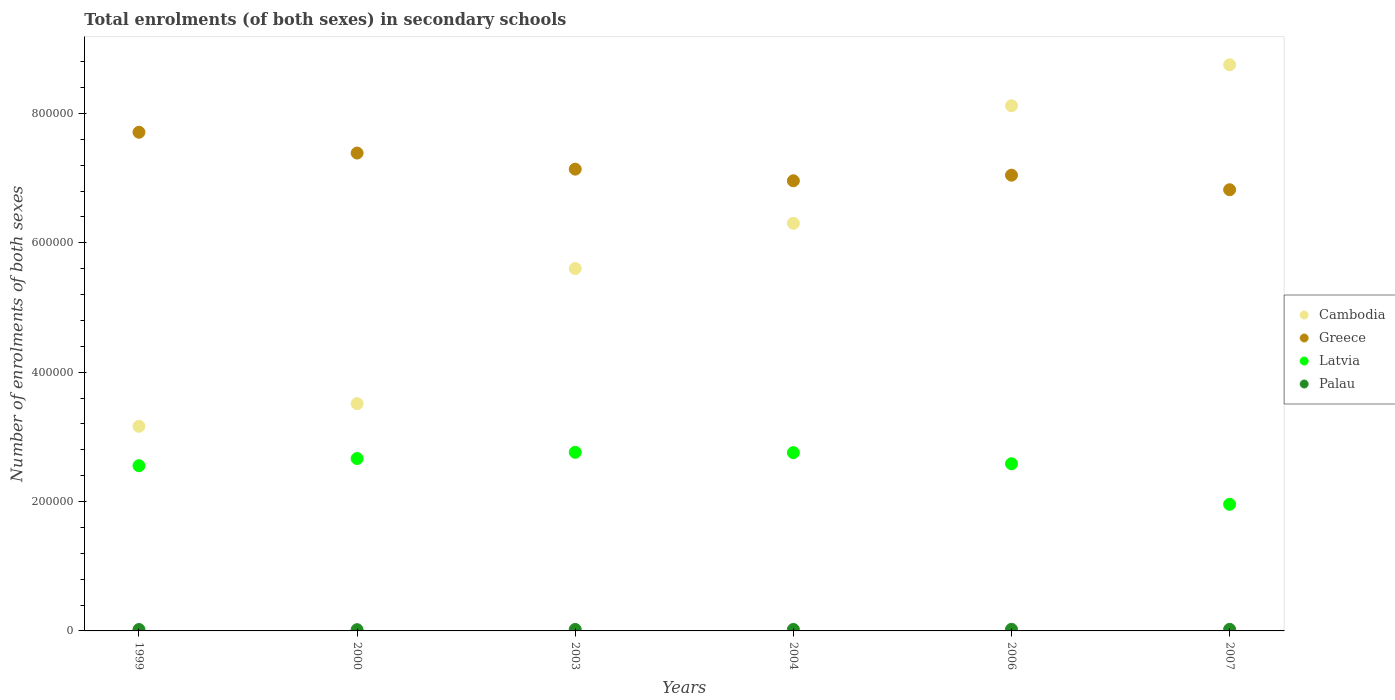How many different coloured dotlines are there?
Give a very brief answer. 4. Is the number of dotlines equal to the number of legend labels?
Ensure brevity in your answer.  Yes. What is the number of enrolments in secondary schools in Cambodia in 2006?
Your response must be concise. 8.12e+05. Across all years, what is the maximum number of enrolments in secondary schools in Latvia?
Your answer should be compact. 2.76e+05. Across all years, what is the minimum number of enrolments in secondary schools in Latvia?
Keep it short and to the point. 1.96e+05. In which year was the number of enrolments in secondary schools in Palau minimum?
Provide a short and direct response. 2000. What is the total number of enrolments in secondary schools in Greece in the graph?
Offer a very short reply. 4.31e+06. What is the difference between the number of enrolments in secondary schools in Greece in 2003 and that in 2004?
Your answer should be compact. 1.80e+04. What is the difference between the number of enrolments in secondary schools in Palau in 1999 and the number of enrolments in secondary schools in Greece in 2000?
Your answer should be compact. -7.37e+05. What is the average number of enrolments in secondary schools in Palau per year?
Provide a short and direct response. 2260.67. In the year 2003, what is the difference between the number of enrolments in secondary schools in Palau and number of enrolments in secondary schools in Latvia?
Ensure brevity in your answer.  -2.74e+05. What is the ratio of the number of enrolments in secondary schools in Cambodia in 2006 to that in 2007?
Offer a terse response. 0.93. Is the difference between the number of enrolments in secondary schools in Palau in 2000 and 2003 greater than the difference between the number of enrolments in secondary schools in Latvia in 2000 and 2003?
Your answer should be very brief. Yes. What is the difference between the highest and the second highest number of enrolments in secondary schools in Cambodia?
Offer a terse response. 6.33e+04. What is the difference between the highest and the lowest number of enrolments in secondary schools in Greece?
Ensure brevity in your answer.  8.89e+04. In how many years, is the number of enrolments in secondary schools in Cambodia greater than the average number of enrolments in secondary schools in Cambodia taken over all years?
Offer a very short reply. 3. Is the sum of the number of enrolments in secondary schools in Cambodia in 2000 and 2006 greater than the maximum number of enrolments in secondary schools in Greece across all years?
Your answer should be very brief. Yes. Is it the case that in every year, the sum of the number of enrolments in secondary schools in Palau and number of enrolments in secondary schools in Greece  is greater than the number of enrolments in secondary schools in Cambodia?
Provide a short and direct response. No. Does the number of enrolments in secondary schools in Palau monotonically increase over the years?
Provide a short and direct response. No. Is the number of enrolments in secondary schools in Cambodia strictly greater than the number of enrolments in secondary schools in Latvia over the years?
Your answer should be very brief. Yes. How many dotlines are there?
Your answer should be very brief. 4. How many years are there in the graph?
Your answer should be compact. 6. What is the difference between two consecutive major ticks on the Y-axis?
Keep it short and to the point. 2.00e+05. Does the graph contain any zero values?
Your response must be concise. No. What is the title of the graph?
Provide a short and direct response. Total enrolments (of both sexes) in secondary schools. Does "North America" appear as one of the legend labels in the graph?
Your response must be concise. No. What is the label or title of the X-axis?
Ensure brevity in your answer.  Years. What is the label or title of the Y-axis?
Offer a very short reply. Number of enrolments of both sexes. What is the Number of enrolments of both sexes in Cambodia in 1999?
Your response must be concise. 3.16e+05. What is the Number of enrolments of both sexes in Greece in 1999?
Your answer should be compact. 7.71e+05. What is the Number of enrolments of both sexes of Latvia in 1999?
Provide a succinct answer. 2.55e+05. What is the Number of enrolments of both sexes of Palau in 1999?
Offer a very short reply. 2177. What is the Number of enrolments of both sexes of Cambodia in 2000?
Your response must be concise. 3.51e+05. What is the Number of enrolments of both sexes of Greece in 2000?
Provide a short and direct response. 7.39e+05. What is the Number of enrolments of both sexes in Latvia in 2000?
Give a very brief answer. 2.66e+05. What is the Number of enrolments of both sexes in Palau in 2000?
Offer a terse response. 1901. What is the Number of enrolments of both sexes of Cambodia in 2003?
Your response must be concise. 5.60e+05. What is the Number of enrolments of both sexes in Greece in 2003?
Offer a very short reply. 7.14e+05. What is the Number of enrolments of both sexes in Latvia in 2003?
Your answer should be compact. 2.76e+05. What is the Number of enrolments of both sexes of Palau in 2003?
Your answer should be very brief. 2271. What is the Number of enrolments of both sexes in Cambodia in 2004?
Provide a short and direct response. 6.30e+05. What is the Number of enrolments of both sexes in Greece in 2004?
Make the answer very short. 6.96e+05. What is the Number of enrolments of both sexes in Latvia in 2004?
Provide a succinct answer. 2.76e+05. What is the Number of enrolments of both sexes in Palau in 2004?
Your answer should be compact. 2273. What is the Number of enrolments of both sexes in Cambodia in 2006?
Give a very brief answer. 8.12e+05. What is the Number of enrolments of both sexes of Greece in 2006?
Your response must be concise. 7.05e+05. What is the Number of enrolments of both sexes in Latvia in 2006?
Make the answer very short. 2.58e+05. What is the Number of enrolments of both sexes in Palau in 2006?
Your response must be concise. 2494. What is the Number of enrolments of both sexes of Cambodia in 2007?
Offer a terse response. 8.75e+05. What is the Number of enrolments of both sexes of Greece in 2007?
Offer a terse response. 6.82e+05. What is the Number of enrolments of both sexes of Latvia in 2007?
Provide a short and direct response. 1.96e+05. What is the Number of enrolments of both sexes of Palau in 2007?
Your answer should be very brief. 2448. Across all years, what is the maximum Number of enrolments of both sexes in Cambodia?
Provide a short and direct response. 8.75e+05. Across all years, what is the maximum Number of enrolments of both sexes in Greece?
Provide a short and direct response. 7.71e+05. Across all years, what is the maximum Number of enrolments of both sexes of Latvia?
Provide a short and direct response. 2.76e+05. Across all years, what is the maximum Number of enrolments of both sexes in Palau?
Ensure brevity in your answer.  2494. Across all years, what is the minimum Number of enrolments of both sexes in Cambodia?
Make the answer very short. 3.16e+05. Across all years, what is the minimum Number of enrolments of both sexes in Greece?
Keep it short and to the point. 6.82e+05. Across all years, what is the minimum Number of enrolments of both sexes of Latvia?
Provide a short and direct response. 1.96e+05. Across all years, what is the minimum Number of enrolments of both sexes in Palau?
Your answer should be compact. 1901. What is the total Number of enrolments of both sexes in Cambodia in the graph?
Keep it short and to the point. 3.54e+06. What is the total Number of enrolments of both sexes of Greece in the graph?
Offer a very short reply. 4.31e+06. What is the total Number of enrolments of both sexes of Latvia in the graph?
Ensure brevity in your answer.  1.53e+06. What is the total Number of enrolments of both sexes in Palau in the graph?
Provide a short and direct response. 1.36e+04. What is the difference between the Number of enrolments of both sexes of Cambodia in 1999 and that in 2000?
Offer a terse response. -3.50e+04. What is the difference between the Number of enrolments of both sexes of Greece in 1999 and that in 2000?
Give a very brief answer. 3.21e+04. What is the difference between the Number of enrolments of both sexes in Latvia in 1999 and that in 2000?
Make the answer very short. -1.11e+04. What is the difference between the Number of enrolments of both sexes of Palau in 1999 and that in 2000?
Your answer should be compact. 276. What is the difference between the Number of enrolments of both sexes of Cambodia in 1999 and that in 2003?
Give a very brief answer. -2.44e+05. What is the difference between the Number of enrolments of both sexes of Greece in 1999 and that in 2003?
Give a very brief answer. 5.70e+04. What is the difference between the Number of enrolments of both sexes in Latvia in 1999 and that in 2003?
Your answer should be very brief. -2.07e+04. What is the difference between the Number of enrolments of both sexes of Palau in 1999 and that in 2003?
Keep it short and to the point. -94. What is the difference between the Number of enrolments of both sexes in Cambodia in 1999 and that in 2004?
Your response must be concise. -3.14e+05. What is the difference between the Number of enrolments of both sexes of Greece in 1999 and that in 2004?
Provide a short and direct response. 7.50e+04. What is the difference between the Number of enrolments of both sexes in Latvia in 1999 and that in 2004?
Give a very brief answer. -2.02e+04. What is the difference between the Number of enrolments of both sexes of Palau in 1999 and that in 2004?
Provide a succinct answer. -96. What is the difference between the Number of enrolments of both sexes in Cambodia in 1999 and that in 2006?
Your answer should be very brief. -4.95e+05. What is the difference between the Number of enrolments of both sexes of Greece in 1999 and that in 2006?
Give a very brief answer. 6.64e+04. What is the difference between the Number of enrolments of both sexes of Latvia in 1999 and that in 2006?
Provide a succinct answer. -3051. What is the difference between the Number of enrolments of both sexes of Palau in 1999 and that in 2006?
Make the answer very short. -317. What is the difference between the Number of enrolments of both sexes of Cambodia in 1999 and that in 2007?
Provide a short and direct response. -5.59e+05. What is the difference between the Number of enrolments of both sexes in Greece in 1999 and that in 2007?
Provide a short and direct response. 8.89e+04. What is the difference between the Number of enrolments of both sexes in Latvia in 1999 and that in 2007?
Your response must be concise. 5.96e+04. What is the difference between the Number of enrolments of both sexes of Palau in 1999 and that in 2007?
Provide a short and direct response. -271. What is the difference between the Number of enrolments of both sexes in Cambodia in 2000 and that in 2003?
Your response must be concise. -2.09e+05. What is the difference between the Number of enrolments of both sexes in Greece in 2000 and that in 2003?
Give a very brief answer. 2.49e+04. What is the difference between the Number of enrolments of both sexes of Latvia in 2000 and that in 2003?
Make the answer very short. -9574. What is the difference between the Number of enrolments of both sexes in Palau in 2000 and that in 2003?
Make the answer very short. -370. What is the difference between the Number of enrolments of both sexes of Cambodia in 2000 and that in 2004?
Keep it short and to the point. -2.79e+05. What is the difference between the Number of enrolments of both sexes in Greece in 2000 and that in 2004?
Your response must be concise. 4.29e+04. What is the difference between the Number of enrolments of both sexes in Latvia in 2000 and that in 2004?
Provide a succinct answer. -9088. What is the difference between the Number of enrolments of both sexes in Palau in 2000 and that in 2004?
Give a very brief answer. -372. What is the difference between the Number of enrolments of both sexes in Cambodia in 2000 and that in 2006?
Your answer should be very brief. -4.60e+05. What is the difference between the Number of enrolments of both sexes in Greece in 2000 and that in 2006?
Give a very brief answer. 3.42e+04. What is the difference between the Number of enrolments of both sexes of Latvia in 2000 and that in 2006?
Your answer should be compact. 8066. What is the difference between the Number of enrolments of both sexes in Palau in 2000 and that in 2006?
Offer a very short reply. -593. What is the difference between the Number of enrolments of both sexes of Cambodia in 2000 and that in 2007?
Offer a very short reply. -5.24e+05. What is the difference between the Number of enrolments of both sexes in Greece in 2000 and that in 2007?
Ensure brevity in your answer.  5.67e+04. What is the difference between the Number of enrolments of both sexes of Latvia in 2000 and that in 2007?
Your answer should be very brief. 7.08e+04. What is the difference between the Number of enrolments of both sexes of Palau in 2000 and that in 2007?
Your answer should be compact. -547. What is the difference between the Number of enrolments of both sexes of Cambodia in 2003 and that in 2004?
Offer a terse response. -6.99e+04. What is the difference between the Number of enrolments of both sexes in Greece in 2003 and that in 2004?
Your answer should be very brief. 1.80e+04. What is the difference between the Number of enrolments of both sexes in Latvia in 2003 and that in 2004?
Keep it short and to the point. 486. What is the difference between the Number of enrolments of both sexes of Cambodia in 2003 and that in 2006?
Keep it short and to the point. -2.52e+05. What is the difference between the Number of enrolments of both sexes of Greece in 2003 and that in 2006?
Make the answer very short. 9335. What is the difference between the Number of enrolments of both sexes in Latvia in 2003 and that in 2006?
Provide a short and direct response. 1.76e+04. What is the difference between the Number of enrolments of both sexes in Palau in 2003 and that in 2006?
Offer a terse response. -223. What is the difference between the Number of enrolments of both sexes of Cambodia in 2003 and that in 2007?
Make the answer very short. -3.15e+05. What is the difference between the Number of enrolments of both sexes of Greece in 2003 and that in 2007?
Make the answer very short. 3.18e+04. What is the difference between the Number of enrolments of both sexes of Latvia in 2003 and that in 2007?
Give a very brief answer. 8.03e+04. What is the difference between the Number of enrolments of both sexes of Palau in 2003 and that in 2007?
Give a very brief answer. -177. What is the difference between the Number of enrolments of both sexes in Cambodia in 2004 and that in 2006?
Provide a short and direct response. -1.82e+05. What is the difference between the Number of enrolments of both sexes of Greece in 2004 and that in 2006?
Provide a short and direct response. -8677. What is the difference between the Number of enrolments of both sexes in Latvia in 2004 and that in 2006?
Your answer should be compact. 1.72e+04. What is the difference between the Number of enrolments of both sexes of Palau in 2004 and that in 2006?
Give a very brief answer. -221. What is the difference between the Number of enrolments of both sexes in Cambodia in 2004 and that in 2007?
Provide a succinct answer. -2.45e+05. What is the difference between the Number of enrolments of both sexes of Greece in 2004 and that in 2007?
Offer a very short reply. 1.38e+04. What is the difference between the Number of enrolments of both sexes of Latvia in 2004 and that in 2007?
Provide a short and direct response. 7.98e+04. What is the difference between the Number of enrolments of both sexes of Palau in 2004 and that in 2007?
Offer a very short reply. -175. What is the difference between the Number of enrolments of both sexes of Cambodia in 2006 and that in 2007?
Provide a short and direct response. -6.33e+04. What is the difference between the Number of enrolments of both sexes of Greece in 2006 and that in 2007?
Give a very brief answer. 2.25e+04. What is the difference between the Number of enrolments of both sexes in Latvia in 2006 and that in 2007?
Offer a terse response. 6.27e+04. What is the difference between the Number of enrolments of both sexes in Cambodia in 1999 and the Number of enrolments of both sexes in Greece in 2000?
Keep it short and to the point. -4.22e+05. What is the difference between the Number of enrolments of both sexes in Cambodia in 1999 and the Number of enrolments of both sexes in Latvia in 2000?
Make the answer very short. 4.98e+04. What is the difference between the Number of enrolments of both sexes of Cambodia in 1999 and the Number of enrolments of both sexes of Palau in 2000?
Offer a terse response. 3.14e+05. What is the difference between the Number of enrolments of both sexes of Greece in 1999 and the Number of enrolments of both sexes of Latvia in 2000?
Offer a very short reply. 5.04e+05. What is the difference between the Number of enrolments of both sexes in Greece in 1999 and the Number of enrolments of both sexes in Palau in 2000?
Offer a terse response. 7.69e+05. What is the difference between the Number of enrolments of both sexes in Latvia in 1999 and the Number of enrolments of both sexes in Palau in 2000?
Make the answer very short. 2.53e+05. What is the difference between the Number of enrolments of both sexes of Cambodia in 1999 and the Number of enrolments of both sexes of Greece in 2003?
Offer a very short reply. -3.98e+05. What is the difference between the Number of enrolments of both sexes of Cambodia in 1999 and the Number of enrolments of both sexes of Latvia in 2003?
Make the answer very short. 4.03e+04. What is the difference between the Number of enrolments of both sexes of Cambodia in 1999 and the Number of enrolments of both sexes of Palau in 2003?
Your response must be concise. 3.14e+05. What is the difference between the Number of enrolments of both sexes of Greece in 1999 and the Number of enrolments of both sexes of Latvia in 2003?
Your answer should be very brief. 4.95e+05. What is the difference between the Number of enrolments of both sexes of Greece in 1999 and the Number of enrolments of both sexes of Palau in 2003?
Offer a terse response. 7.69e+05. What is the difference between the Number of enrolments of both sexes in Latvia in 1999 and the Number of enrolments of both sexes in Palau in 2003?
Your response must be concise. 2.53e+05. What is the difference between the Number of enrolments of both sexes in Cambodia in 1999 and the Number of enrolments of both sexes in Greece in 2004?
Keep it short and to the point. -3.79e+05. What is the difference between the Number of enrolments of both sexes of Cambodia in 1999 and the Number of enrolments of both sexes of Latvia in 2004?
Ensure brevity in your answer.  4.08e+04. What is the difference between the Number of enrolments of both sexes in Cambodia in 1999 and the Number of enrolments of both sexes in Palau in 2004?
Give a very brief answer. 3.14e+05. What is the difference between the Number of enrolments of both sexes in Greece in 1999 and the Number of enrolments of both sexes in Latvia in 2004?
Your answer should be compact. 4.95e+05. What is the difference between the Number of enrolments of both sexes in Greece in 1999 and the Number of enrolments of both sexes in Palau in 2004?
Make the answer very short. 7.69e+05. What is the difference between the Number of enrolments of both sexes of Latvia in 1999 and the Number of enrolments of both sexes of Palau in 2004?
Provide a short and direct response. 2.53e+05. What is the difference between the Number of enrolments of both sexes of Cambodia in 1999 and the Number of enrolments of both sexes of Greece in 2006?
Your answer should be compact. -3.88e+05. What is the difference between the Number of enrolments of both sexes of Cambodia in 1999 and the Number of enrolments of both sexes of Latvia in 2006?
Provide a short and direct response. 5.79e+04. What is the difference between the Number of enrolments of both sexes of Cambodia in 1999 and the Number of enrolments of both sexes of Palau in 2006?
Ensure brevity in your answer.  3.14e+05. What is the difference between the Number of enrolments of both sexes of Greece in 1999 and the Number of enrolments of both sexes of Latvia in 2006?
Your answer should be compact. 5.12e+05. What is the difference between the Number of enrolments of both sexes in Greece in 1999 and the Number of enrolments of both sexes in Palau in 2006?
Ensure brevity in your answer.  7.68e+05. What is the difference between the Number of enrolments of both sexes in Latvia in 1999 and the Number of enrolments of both sexes in Palau in 2006?
Your response must be concise. 2.53e+05. What is the difference between the Number of enrolments of both sexes of Cambodia in 1999 and the Number of enrolments of both sexes of Greece in 2007?
Offer a very short reply. -3.66e+05. What is the difference between the Number of enrolments of both sexes in Cambodia in 1999 and the Number of enrolments of both sexes in Latvia in 2007?
Offer a very short reply. 1.21e+05. What is the difference between the Number of enrolments of both sexes of Cambodia in 1999 and the Number of enrolments of both sexes of Palau in 2007?
Keep it short and to the point. 3.14e+05. What is the difference between the Number of enrolments of both sexes in Greece in 1999 and the Number of enrolments of both sexes in Latvia in 2007?
Your response must be concise. 5.75e+05. What is the difference between the Number of enrolments of both sexes of Greece in 1999 and the Number of enrolments of both sexes of Palau in 2007?
Offer a terse response. 7.68e+05. What is the difference between the Number of enrolments of both sexes of Latvia in 1999 and the Number of enrolments of both sexes of Palau in 2007?
Provide a succinct answer. 2.53e+05. What is the difference between the Number of enrolments of both sexes in Cambodia in 2000 and the Number of enrolments of both sexes in Greece in 2003?
Your answer should be compact. -3.62e+05. What is the difference between the Number of enrolments of both sexes in Cambodia in 2000 and the Number of enrolments of both sexes in Latvia in 2003?
Keep it short and to the point. 7.53e+04. What is the difference between the Number of enrolments of both sexes of Cambodia in 2000 and the Number of enrolments of both sexes of Palau in 2003?
Your answer should be compact. 3.49e+05. What is the difference between the Number of enrolments of both sexes of Greece in 2000 and the Number of enrolments of both sexes of Latvia in 2003?
Offer a very short reply. 4.63e+05. What is the difference between the Number of enrolments of both sexes of Greece in 2000 and the Number of enrolments of both sexes of Palau in 2003?
Give a very brief answer. 7.36e+05. What is the difference between the Number of enrolments of both sexes in Latvia in 2000 and the Number of enrolments of both sexes in Palau in 2003?
Your response must be concise. 2.64e+05. What is the difference between the Number of enrolments of both sexes of Cambodia in 2000 and the Number of enrolments of both sexes of Greece in 2004?
Give a very brief answer. -3.44e+05. What is the difference between the Number of enrolments of both sexes in Cambodia in 2000 and the Number of enrolments of both sexes in Latvia in 2004?
Ensure brevity in your answer.  7.58e+04. What is the difference between the Number of enrolments of both sexes in Cambodia in 2000 and the Number of enrolments of both sexes in Palau in 2004?
Your answer should be very brief. 3.49e+05. What is the difference between the Number of enrolments of both sexes of Greece in 2000 and the Number of enrolments of both sexes of Latvia in 2004?
Your answer should be very brief. 4.63e+05. What is the difference between the Number of enrolments of both sexes of Greece in 2000 and the Number of enrolments of both sexes of Palau in 2004?
Your answer should be very brief. 7.36e+05. What is the difference between the Number of enrolments of both sexes of Latvia in 2000 and the Number of enrolments of both sexes of Palau in 2004?
Your response must be concise. 2.64e+05. What is the difference between the Number of enrolments of both sexes in Cambodia in 2000 and the Number of enrolments of both sexes in Greece in 2006?
Your answer should be compact. -3.53e+05. What is the difference between the Number of enrolments of both sexes in Cambodia in 2000 and the Number of enrolments of both sexes in Latvia in 2006?
Provide a short and direct response. 9.29e+04. What is the difference between the Number of enrolments of both sexes of Cambodia in 2000 and the Number of enrolments of both sexes of Palau in 2006?
Offer a terse response. 3.49e+05. What is the difference between the Number of enrolments of both sexes in Greece in 2000 and the Number of enrolments of both sexes in Latvia in 2006?
Offer a very short reply. 4.80e+05. What is the difference between the Number of enrolments of both sexes of Greece in 2000 and the Number of enrolments of both sexes of Palau in 2006?
Your answer should be very brief. 7.36e+05. What is the difference between the Number of enrolments of both sexes in Latvia in 2000 and the Number of enrolments of both sexes in Palau in 2006?
Offer a terse response. 2.64e+05. What is the difference between the Number of enrolments of both sexes in Cambodia in 2000 and the Number of enrolments of both sexes in Greece in 2007?
Your response must be concise. -3.31e+05. What is the difference between the Number of enrolments of both sexes of Cambodia in 2000 and the Number of enrolments of both sexes of Latvia in 2007?
Keep it short and to the point. 1.56e+05. What is the difference between the Number of enrolments of both sexes of Cambodia in 2000 and the Number of enrolments of both sexes of Palau in 2007?
Offer a very short reply. 3.49e+05. What is the difference between the Number of enrolments of both sexes of Greece in 2000 and the Number of enrolments of both sexes of Latvia in 2007?
Make the answer very short. 5.43e+05. What is the difference between the Number of enrolments of both sexes in Greece in 2000 and the Number of enrolments of both sexes in Palau in 2007?
Ensure brevity in your answer.  7.36e+05. What is the difference between the Number of enrolments of both sexes in Latvia in 2000 and the Number of enrolments of both sexes in Palau in 2007?
Ensure brevity in your answer.  2.64e+05. What is the difference between the Number of enrolments of both sexes in Cambodia in 2003 and the Number of enrolments of both sexes in Greece in 2004?
Provide a succinct answer. -1.36e+05. What is the difference between the Number of enrolments of both sexes of Cambodia in 2003 and the Number of enrolments of both sexes of Latvia in 2004?
Keep it short and to the point. 2.85e+05. What is the difference between the Number of enrolments of both sexes of Cambodia in 2003 and the Number of enrolments of both sexes of Palau in 2004?
Ensure brevity in your answer.  5.58e+05. What is the difference between the Number of enrolments of both sexes of Greece in 2003 and the Number of enrolments of both sexes of Latvia in 2004?
Give a very brief answer. 4.38e+05. What is the difference between the Number of enrolments of both sexes of Greece in 2003 and the Number of enrolments of both sexes of Palau in 2004?
Give a very brief answer. 7.12e+05. What is the difference between the Number of enrolments of both sexes in Latvia in 2003 and the Number of enrolments of both sexes in Palau in 2004?
Keep it short and to the point. 2.74e+05. What is the difference between the Number of enrolments of both sexes in Cambodia in 2003 and the Number of enrolments of both sexes in Greece in 2006?
Offer a very short reply. -1.44e+05. What is the difference between the Number of enrolments of both sexes in Cambodia in 2003 and the Number of enrolments of both sexes in Latvia in 2006?
Give a very brief answer. 3.02e+05. What is the difference between the Number of enrolments of both sexes in Cambodia in 2003 and the Number of enrolments of both sexes in Palau in 2006?
Your response must be concise. 5.58e+05. What is the difference between the Number of enrolments of both sexes in Greece in 2003 and the Number of enrolments of both sexes in Latvia in 2006?
Offer a very short reply. 4.55e+05. What is the difference between the Number of enrolments of both sexes of Greece in 2003 and the Number of enrolments of both sexes of Palau in 2006?
Your answer should be very brief. 7.11e+05. What is the difference between the Number of enrolments of both sexes of Latvia in 2003 and the Number of enrolments of both sexes of Palau in 2006?
Provide a succinct answer. 2.74e+05. What is the difference between the Number of enrolments of both sexes in Cambodia in 2003 and the Number of enrolments of both sexes in Greece in 2007?
Your answer should be compact. -1.22e+05. What is the difference between the Number of enrolments of both sexes of Cambodia in 2003 and the Number of enrolments of both sexes of Latvia in 2007?
Provide a succinct answer. 3.64e+05. What is the difference between the Number of enrolments of both sexes in Cambodia in 2003 and the Number of enrolments of both sexes in Palau in 2007?
Your answer should be very brief. 5.58e+05. What is the difference between the Number of enrolments of both sexes in Greece in 2003 and the Number of enrolments of both sexes in Latvia in 2007?
Your answer should be very brief. 5.18e+05. What is the difference between the Number of enrolments of both sexes of Greece in 2003 and the Number of enrolments of both sexes of Palau in 2007?
Keep it short and to the point. 7.11e+05. What is the difference between the Number of enrolments of both sexes of Latvia in 2003 and the Number of enrolments of both sexes of Palau in 2007?
Provide a short and direct response. 2.74e+05. What is the difference between the Number of enrolments of both sexes of Cambodia in 2004 and the Number of enrolments of both sexes of Greece in 2006?
Make the answer very short. -7.44e+04. What is the difference between the Number of enrolments of both sexes of Cambodia in 2004 and the Number of enrolments of both sexes of Latvia in 2006?
Ensure brevity in your answer.  3.72e+05. What is the difference between the Number of enrolments of both sexes in Cambodia in 2004 and the Number of enrolments of both sexes in Palau in 2006?
Your answer should be very brief. 6.28e+05. What is the difference between the Number of enrolments of both sexes of Greece in 2004 and the Number of enrolments of both sexes of Latvia in 2006?
Make the answer very short. 4.37e+05. What is the difference between the Number of enrolments of both sexes in Greece in 2004 and the Number of enrolments of both sexes in Palau in 2006?
Your answer should be very brief. 6.93e+05. What is the difference between the Number of enrolments of both sexes in Latvia in 2004 and the Number of enrolments of both sexes in Palau in 2006?
Your answer should be very brief. 2.73e+05. What is the difference between the Number of enrolments of both sexes in Cambodia in 2004 and the Number of enrolments of both sexes in Greece in 2007?
Keep it short and to the point. -5.19e+04. What is the difference between the Number of enrolments of both sexes of Cambodia in 2004 and the Number of enrolments of both sexes of Latvia in 2007?
Provide a short and direct response. 4.34e+05. What is the difference between the Number of enrolments of both sexes in Cambodia in 2004 and the Number of enrolments of both sexes in Palau in 2007?
Provide a succinct answer. 6.28e+05. What is the difference between the Number of enrolments of both sexes in Greece in 2004 and the Number of enrolments of both sexes in Latvia in 2007?
Provide a succinct answer. 5.00e+05. What is the difference between the Number of enrolments of both sexes in Greece in 2004 and the Number of enrolments of both sexes in Palau in 2007?
Your answer should be compact. 6.93e+05. What is the difference between the Number of enrolments of both sexes of Latvia in 2004 and the Number of enrolments of both sexes of Palau in 2007?
Provide a short and direct response. 2.73e+05. What is the difference between the Number of enrolments of both sexes of Cambodia in 2006 and the Number of enrolments of both sexes of Greece in 2007?
Provide a short and direct response. 1.30e+05. What is the difference between the Number of enrolments of both sexes of Cambodia in 2006 and the Number of enrolments of both sexes of Latvia in 2007?
Offer a terse response. 6.16e+05. What is the difference between the Number of enrolments of both sexes of Cambodia in 2006 and the Number of enrolments of both sexes of Palau in 2007?
Make the answer very short. 8.09e+05. What is the difference between the Number of enrolments of both sexes of Greece in 2006 and the Number of enrolments of both sexes of Latvia in 2007?
Give a very brief answer. 5.09e+05. What is the difference between the Number of enrolments of both sexes of Greece in 2006 and the Number of enrolments of both sexes of Palau in 2007?
Offer a very short reply. 7.02e+05. What is the difference between the Number of enrolments of both sexes of Latvia in 2006 and the Number of enrolments of both sexes of Palau in 2007?
Your answer should be very brief. 2.56e+05. What is the average Number of enrolments of both sexes of Cambodia per year?
Make the answer very short. 5.91e+05. What is the average Number of enrolments of both sexes of Greece per year?
Your answer should be very brief. 7.18e+05. What is the average Number of enrolments of both sexes in Latvia per year?
Offer a very short reply. 2.55e+05. What is the average Number of enrolments of both sexes in Palau per year?
Your answer should be compact. 2260.67. In the year 1999, what is the difference between the Number of enrolments of both sexes of Cambodia and Number of enrolments of both sexes of Greece?
Provide a succinct answer. -4.55e+05. In the year 1999, what is the difference between the Number of enrolments of both sexes in Cambodia and Number of enrolments of both sexes in Latvia?
Offer a very short reply. 6.10e+04. In the year 1999, what is the difference between the Number of enrolments of both sexes of Cambodia and Number of enrolments of both sexes of Palau?
Your response must be concise. 3.14e+05. In the year 1999, what is the difference between the Number of enrolments of both sexes in Greece and Number of enrolments of both sexes in Latvia?
Your answer should be compact. 5.16e+05. In the year 1999, what is the difference between the Number of enrolments of both sexes in Greece and Number of enrolments of both sexes in Palau?
Provide a succinct answer. 7.69e+05. In the year 1999, what is the difference between the Number of enrolments of both sexes of Latvia and Number of enrolments of both sexes of Palau?
Ensure brevity in your answer.  2.53e+05. In the year 2000, what is the difference between the Number of enrolments of both sexes of Cambodia and Number of enrolments of both sexes of Greece?
Make the answer very short. -3.87e+05. In the year 2000, what is the difference between the Number of enrolments of both sexes in Cambodia and Number of enrolments of both sexes in Latvia?
Provide a short and direct response. 8.49e+04. In the year 2000, what is the difference between the Number of enrolments of both sexes in Cambodia and Number of enrolments of both sexes in Palau?
Give a very brief answer. 3.49e+05. In the year 2000, what is the difference between the Number of enrolments of both sexes of Greece and Number of enrolments of both sexes of Latvia?
Provide a succinct answer. 4.72e+05. In the year 2000, what is the difference between the Number of enrolments of both sexes in Greece and Number of enrolments of both sexes in Palau?
Your answer should be very brief. 7.37e+05. In the year 2000, what is the difference between the Number of enrolments of both sexes of Latvia and Number of enrolments of both sexes of Palau?
Your answer should be very brief. 2.65e+05. In the year 2003, what is the difference between the Number of enrolments of both sexes of Cambodia and Number of enrolments of both sexes of Greece?
Provide a succinct answer. -1.54e+05. In the year 2003, what is the difference between the Number of enrolments of both sexes in Cambodia and Number of enrolments of both sexes in Latvia?
Provide a short and direct response. 2.84e+05. In the year 2003, what is the difference between the Number of enrolments of both sexes in Cambodia and Number of enrolments of both sexes in Palau?
Your response must be concise. 5.58e+05. In the year 2003, what is the difference between the Number of enrolments of both sexes in Greece and Number of enrolments of both sexes in Latvia?
Your answer should be compact. 4.38e+05. In the year 2003, what is the difference between the Number of enrolments of both sexes of Greece and Number of enrolments of both sexes of Palau?
Ensure brevity in your answer.  7.12e+05. In the year 2003, what is the difference between the Number of enrolments of both sexes in Latvia and Number of enrolments of both sexes in Palau?
Give a very brief answer. 2.74e+05. In the year 2004, what is the difference between the Number of enrolments of both sexes in Cambodia and Number of enrolments of both sexes in Greece?
Make the answer very short. -6.57e+04. In the year 2004, what is the difference between the Number of enrolments of both sexes of Cambodia and Number of enrolments of both sexes of Latvia?
Keep it short and to the point. 3.55e+05. In the year 2004, what is the difference between the Number of enrolments of both sexes of Cambodia and Number of enrolments of both sexes of Palau?
Your response must be concise. 6.28e+05. In the year 2004, what is the difference between the Number of enrolments of both sexes of Greece and Number of enrolments of both sexes of Latvia?
Provide a succinct answer. 4.20e+05. In the year 2004, what is the difference between the Number of enrolments of both sexes in Greece and Number of enrolments of both sexes in Palau?
Your answer should be compact. 6.94e+05. In the year 2004, what is the difference between the Number of enrolments of both sexes of Latvia and Number of enrolments of both sexes of Palau?
Make the answer very short. 2.73e+05. In the year 2006, what is the difference between the Number of enrolments of both sexes of Cambodia and Number of enrolments of both sexes of Greece?
Offer a very short reply. 1.07e+05. In the year 2006, what is the difference between the Number of enrolments of both sexes in Cambodia and Number of enrolments of both sexes in Latvia?
Your answer should be very brief. 5.53e+05. In the year 2006, what is the difference between the Number of enrolments of both sexes of Cambodia and Number of enrolments of both sexes of Palau?
Provide a succinct answer. 8.09e+05. In the year 2006, what is the difference between the Number of enrolments of both sexes in Greece and Number of enrolments of both sexes in Latvia?
Provide a short and direct response. 4.46e+05. In the year 2006, what is the difference between the Number of enrolments of both sexes of Greece and Number of enrolments of both sexes of Palau?
Provide a short and direct response. 7.02e+05. In the year 2006, what is the difference between the Number of enrolments of both sexes in Latvia and Number of enrolments of both sexes in Palau?
Give a very brief answer. 2.56e+05. In the year 2007, what is the difference between the Number of enrolments of both sexes of Cambodia and Number of enrolments of both sexes of Greece?
Provide a short and direct response. 1.93e+05. In the year 2007, what is the difference between the Number of enrolments of both sexes of Cambodia and Number of enrolments of both sexes of Latvia?
Offer a very short reply. 6.79e+05. In the year 2007, what is the difference between the Number of enrolments of both sexes in Cambodia and Number of enrolments of both sexes in Palau?
Your response must be concise. 8.73e+05. In the year 2007, what is the difference between the Number of enrolments of both sexes of Greece and Number of enrolments of both sexes of Latvia?
Offer a terse response. 4.86e+05. In the year 2007, what is the difference between the Number of enrolments of both sexes in Greece and Number of enrolments of both sexes in Palau?
Offer a terse response. 6.80e+05. In the year 2007, what is the difference between the Number of enrolments of both sexes of Latvia and Number of enrolments of both sexes of Palau?
Offer a terse response. 1.93e+05. What is the ratio of the Number of enrolments of both sexes in Cambodia in 1999 to that in 2000?
Keep it short and to the point. 0.9. What is the ratio of the Number of enrolments of both sexes in Greece in 1999 to that in 2000?
Provide a succinct answer. 1.04. What is the ratio of the Number of enrolments of both sexes of Latvia in 1999 to that in 2000?
Provide a succinct answer. 0.96. What is the ratio of the Number of enrolments of both sexes of Palau in 1999 to that in 2000?
Your response must be concise. 1.15. What is the ratio of the Number of enrolments of both sexes in Cambodia in 1999 to that in 2003?
Offer a very short reply. 0.56. What is the ratio of the Number of enrolments of both sexes in Greece in 1999 to that in 2003?
Ensure brevity in your answer.  1.08. What is the ratio of the Number of enrolments of both sexes in Latvia in 1999 to that in 2003?
Provide a succinct answer. 0.93. What is the ratio of the Number of enrolments of both sexes of Palau in 1999 to that in 2003?
Your response must be concise. 0.96. What is the ratio of the Number of enrolments of both sexes of Cambodia in 1999 to that in 2004?
Provide a succinct answer. 0.5. What is the ratio of the Number of enrolments of both sexes of Greece in 1999 to that in 2004?
Offer a terse response. 1.11. What is the ratio of the Number of enrolments of both sexes in Latvia in 1999 to that in 2004?
Offer a very short reply. 0.93. What is the ratio of the Number of enrolments of both sexes of Palau in 1999 to that in 2004?
Provide a succinct answer. 0.96. What is the ratio of the Number of enrolments of both sexes of Cambodia in 1999 to that in 2006?
Make the answer very short. 0.39. What is the ratio of the Number of enrolments of both sexes of Greece in 1999 to that in 2006?
Keep it short and to the point. 1.09. What is the ratio of the Number of enrolments of both sexes in Latvia in 1999 to that in 2006?
Make the answer very short. 0.99. What is the ratio of the Number of enrolments of both sexes of Palau in 1999 to that in 2006?
Keep it short and to the point. 0.87. What is the ratio of the Number of enrolments of both sexes of Cambodia in 1999 to that in 2007?
Your answer should be compact. 0.36. What is the ratio of the Number of enrolments of both sexes of Greece in 1999 to that in 2007?
Keep it short and to the point. 1.13. What is the ratio of the Number of enrolments of both sexes of Latvia in 1999 to that in 2007?
Your answer should be compact. 1.3. What is the ratio of the Number of enrolments of both sexes in Palau in 1999 to that in 2007?
Ensure brevity in your answer.  0.89. What is the ratio of the Number of enrolments of both sexes of Cambodia in 2000 to that in 2003?
Provide a short and direct response. 0.63. What is the ratio of the Number of enrolments of both sexes of Greece in 2000 to that in 2003?
Provide a succinct answer. 1.03. What is the ratio of the Number of enrolments of both sexes of Latvia in 2000 to that in 2003?
Provide a short and direct response. 0.97. What is the ratio of the Number of enrolments of both sexes of Palau in 2000 to that in 2003?
Provide a succinct answer. 0.84. What is the ratio of the Number of enrolments of both sexes of Cambodia in 2000 to that in 2004?
Provide a short and direct response. 0.56. What is the ratio of the Number of enrolments of both sexes in Greece in 2000 to that in 2004?
Give a very brief answer. 1.06. What is the ratio of the Number of enrolments of both sexes in Palau in 2000 to that in 2004?
Offer a very short reply. 0.84. What is the ratio of the Number of enrolments of both sexes of Cambodia in 2000 to that in 2006?
Offer a terse response. 0.43. What is the ratio of the Number of enrolments of both sexes of Greece in 2000 to that in 2006?
Ensure brevity in your answer.  1.05. What is the ratio of the Number of enrolments of both sexes in Latvia in 2000 to that in 2006?
Your answer should be compact. 1.03. What is the ratio of the Number of enrolments of both sexes in Palau in 2000 to that in 2006?
Offer a very short reply. 0.76. What is the ratio of the Number of enrolments of both sexes of Cambodia in 2000 to that in 2007?
Keep it short and to the point. 0.4. What is the ratio of the Number of enrolments of both sexes of Greece in 2000 to that in 2007?
Your answer should be compact. 1.08. What is the ratio of the Number of enrolments of both sexes in Latvia in 2000 to that in 2007?
Offer a very short reply. 1.36. What is the ratio of the Number of enrolments of both sexes in Palau in 2000 to that in 2007?
Give a very brief answer. 0.78. What is the ratio of the Number of enrolments of both sexes of Cambodia in 2003 to that in 2004?
Keep it short and to the point. 0.89. What is the ratio of the Number of enrolments of both sexes in Greece in 2003 to that in 2004?
Your answer should be very brief. 1.03. What is the ratio of the Number of enrolments of both sexes in Cambodia in 2003 to that in 2006?
Your answer should be very brief. 0.69. What is the ratio of the Number of enrolments of both sexes in Greece in 2003 to that in 2006?
Provide a succinct answer. 1.01. What is the ratio of the Number of enrolments of both sexes of Latvia in 2003 to that in 2006?
Your answer should be very brief. 1.07. What is the ratio of the Number of enrolments of both sexes of Palau in 2003 to that in 2006?
Offer a terse response. 0.91. What is the ratio of the Number of enrolments of both sexes in Cambodia in 2003 to that in 2007?
Provide a short and direct response. 0.64. What is the ratio of the Number of enrolments of both sexes in Greece in 2003 to that in 2007?
Make the answer very short. 1.05. What is the ratio of the Number of enrolments of both sexes of Latvia in 2003 to that in 2007?
Provide a succinct answer. 1.41. What is the ratio of the Number of enrolments of both sexes of Palau in 2003 to that in 2007?
Make the answer very short. 0.93. What is the ratio of the Number of enrolments of both sexes in Cambodia in 2004 to that in 2006?
Your answer should be very brief. 0.78. What is the ratio of the Number of enrolments of both sexes of Latvia in 2004 to that in 2006?
Provide a succinct answer. 1.07. What is the ratio of the Number of enrolments of both sexes of Palau in 2004 to that in 2006?
Offer a terse response. 0.91. What is the ratio of the Number of enrolments of both sexes in Cambodia in 2004 to that in 2007?
Offer a very short reply. 0.72. What is the ratio of the Number of enrolments of both sexes in Greece in 2004 to that in 2007?
Provide a short and direct response. 1.02. What is the ratio of the Number of enrolments of both sexes of Latvia in 2004 to that in 2007?
Your answer should be compact. 1.41. What is the ratio of the Number of enrolments of both sexes of Palau in 2004 to that in 2007?
Make the answer very short. 0.93. What is the ratio of the Number of enrolments of both sexes in Cambodia in 2006 to that in 2007?
Provide a short and direct response. 0.93. What is the ratio of the Number of enrolments of both sexes of Greece in 2006 to that in 2007?
Your response must be concise. 1.03. What is the ratio of the Number of enrolments of both sexes of Latvia in 2006 to that in 2007?
Offer a very short reply. 1.32. What is the ratio of the Number of enrolments of both sexes in Palau in 2006 to that in 2007?
Make the answer very short. 1.02. What is the difference between the highest and the second highest Number of enrolments of both sexes in Cambodia?
Ensure brevity in your answer.  6.33e+04. What is the difference between the highest and the second highest Number of enrolments of both sexes of Greece?
Your response must be concise. 3.21e+04. What is the difference between the highest and the second highest Number of enrolments of both sexes in Latvia?
Offer a very short reply. 486. What is the difference between the highest and the second highest Number of enrolments of both sexes of Palau?
Keep it short and to the point. 46. What is the difference between the highest and the lowest Number of enrolments of both sexes in Cambodia?
Ensure brevity in your answer.  5.59e+05. What is the difference between the highest and the lowest Number of enrolments of both sexes of Greece?
Provide a succinct answer. 8.89e+04. What is the difference between the highest and the lowest Number of enrolments of both sexes in Latvia?
Ensure brevity in your answer.  8.03e+04. What is the difference between the highest and the lowest Number of enrolments of both sexes in Palau?
Offer a very short reply. 593. 